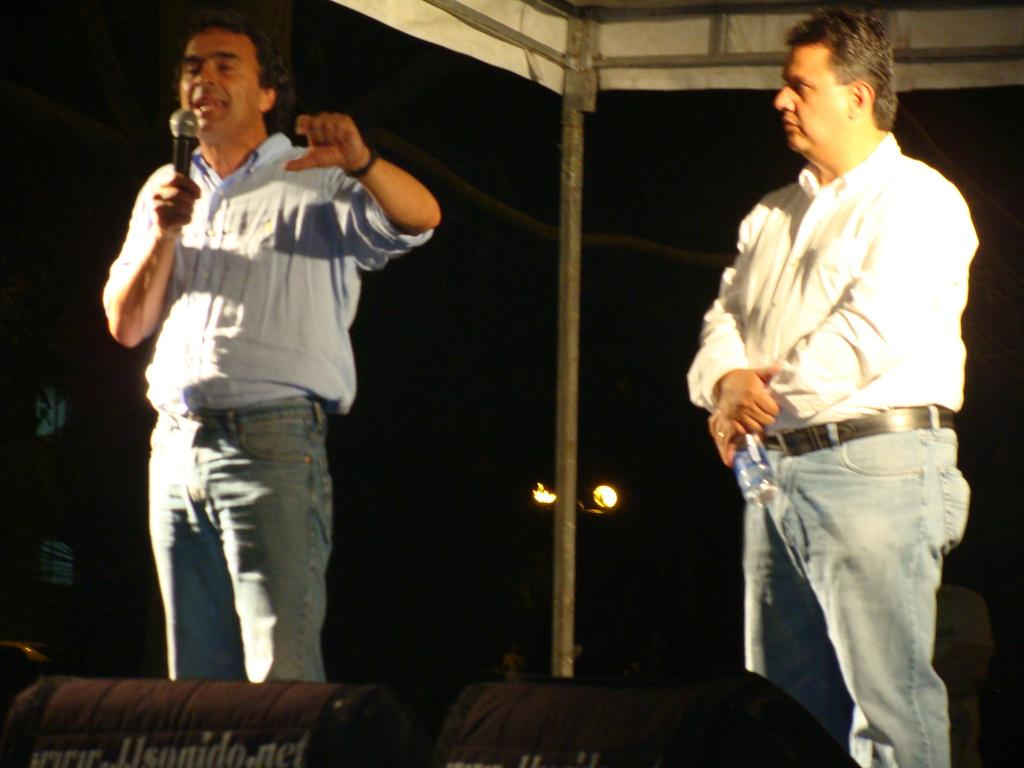How many people are in the image? There are two people in the image. What is one of the people holding? One of the people is holding a mic. What type of writer is visible in the image? There is no writer present in the image. What kind of space is depicted in the image? The image does not depict any specific space; it only shows two people and a mic. 